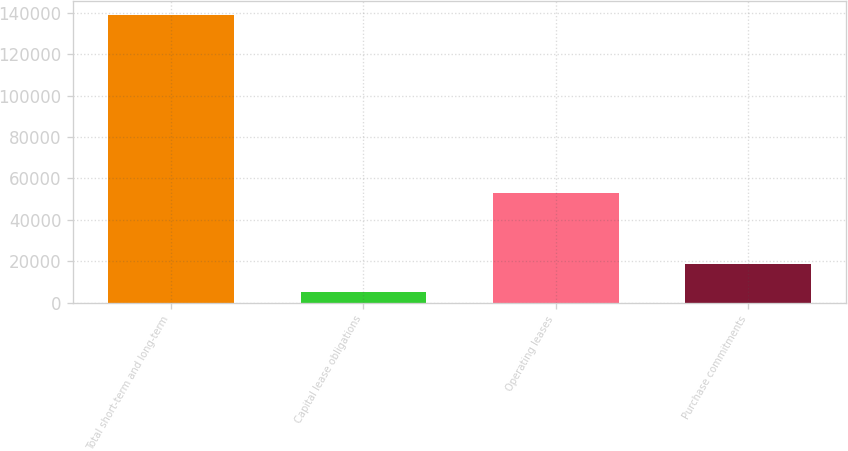Convert chart to OTSL. <chart><loc_0><loc_0><loc_500><loc_500><bar_chart><fcel>Total short-term and long-term<fcel>Capital lease obligations<fcel>Operating leases<fcel>Purchase commitments<nl><fcel>139000<fcel>5308<fcel>52837<fcel>18677.2<nl></chart> 